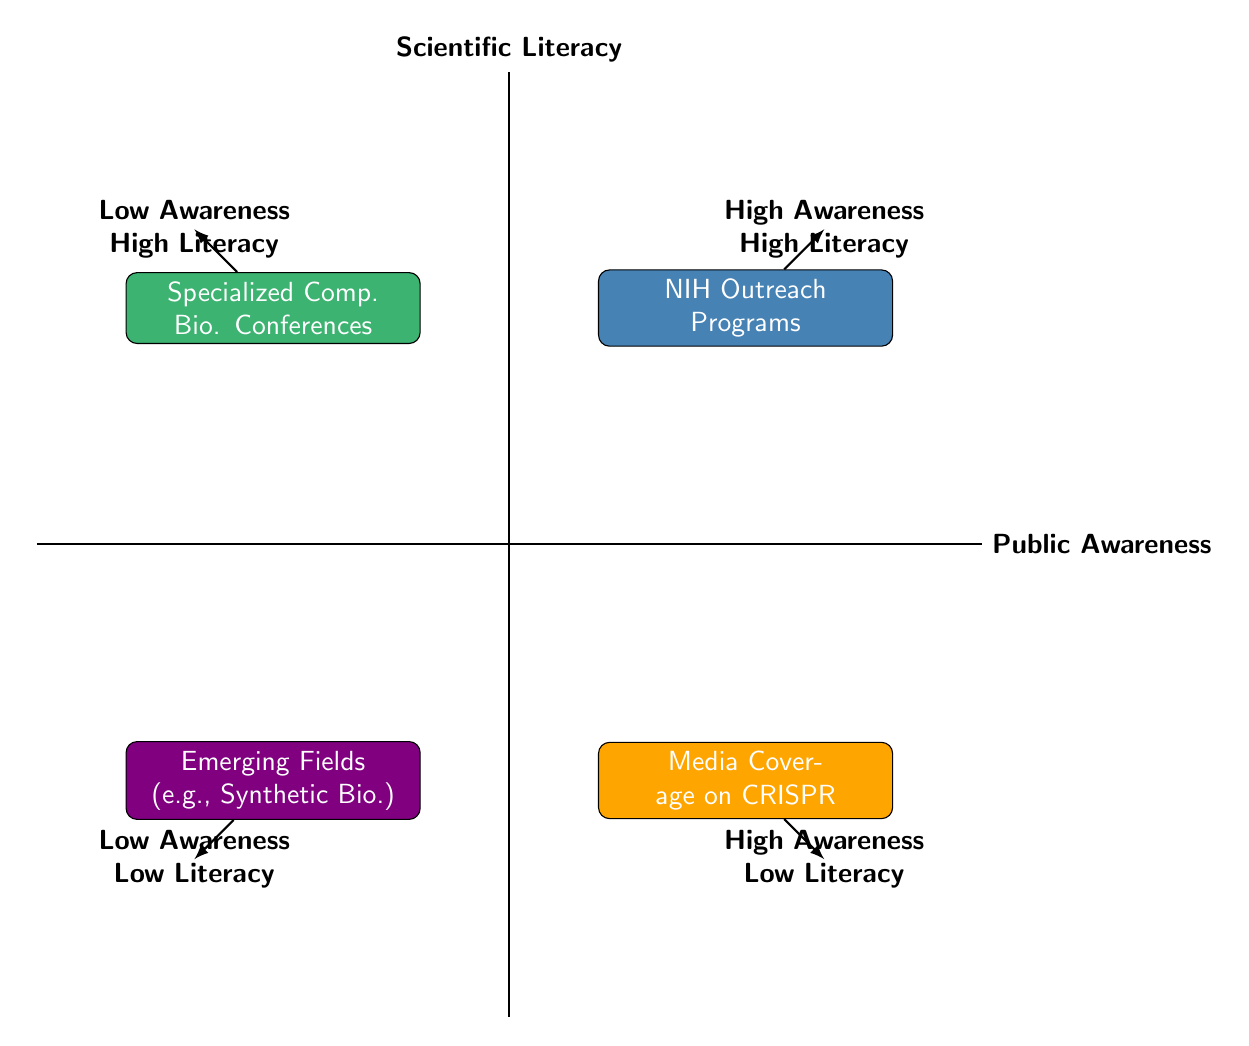What are the two elements in the "High Public Awareness, High Scientific Literacy" quadrant? The "High Public Awareness, High Scientific Literacy" quadrant contains the elements "NIH Outreach Programs" and the description associated with them.
Answer: NIH Outreach Programs How many elements are there in total in the quadrant chart? There are four elements represented in the quadrant chart: NIH Outreach Programs, Media Coverage on CRISPR, Specialized Computational Biology Conferences, and Emerging Fields like Synthetic Biology.
Answer: 4 Which element represents public interest driven by media? The "Media Coverage on CRISPR Technology" represents public interest driven by media but lacks in-depth understanding.
Answer: Media Coverage on CRISPR Technology In which quadrant would you find the "Emerging Fields like Synthetic Biology"? The "Emerging Fields like Synthetic Biology" is found in the "Low Public Awareness, Low Scientific Literacy" quadrant, indicating limited public familiarity.
Answer: Low Public Awareness, Low Scientific Literacy Which quadrant has a specialized focus on knowledge exchange among experts? The quadrant for specialized knowledge exchange among experts is "Low Public Awareness, High Scientific Literacy," which contains "Specialized Computational Biology Conferences."
Answer: Low Public Awareness, High Scientific Literacy What can be inferred about the relationship between public awareness and scientific literacy for the "NIH Outreach Programs"? The "NIH Outreach Programs" indicate a positive relationship, showing high levels of both public awareness and scientific literacy due to effective outreach efforts.
Answer: High Awareness, High Literacy Which element suggests a gap in understanding complex new fields? The element "Emerging Fields like Synthetic Biology" suggests a gap in understanding because of its novelty and complexity, contributing to low awareness and low literacy.
Answer: Emerging Fields like Synthetic Biology Are there any elements that correlate high public awareness with low scientific literacy? Yes, the "Media Coverage on CRISPR Technology" correlates high public awareness with low scientific literacy, reflecting general interest with limited understanding.
Answer: Yes 